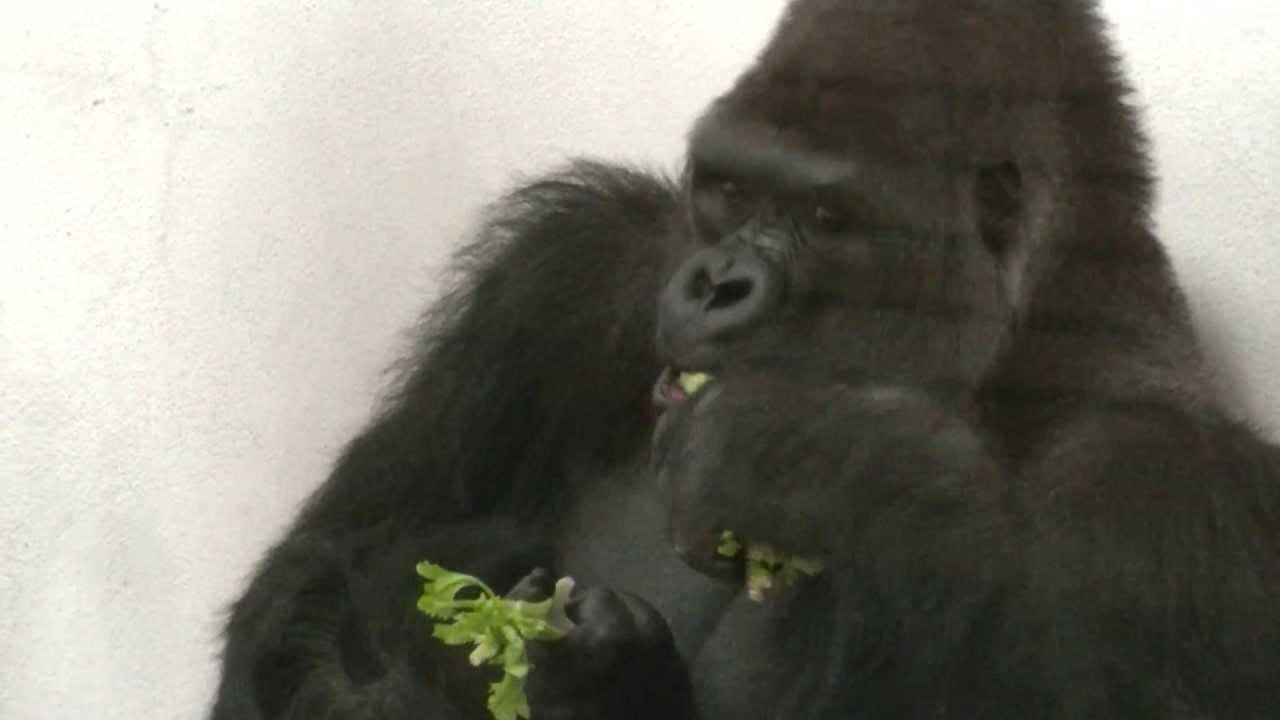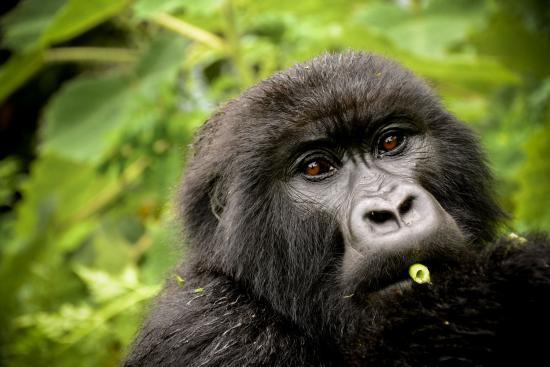The first image is the image on the left, the second image is the image on the right. Analyze the images presented: Is the assertion "In the right image, a gorilla is holding green foliage to its mouth with the arm on the left [of the image]." valid? Answer yes or no. No. The first image is the image on the left, the second image is the image on the right. Considering the images on both sides, is "All of the gorillas are holding food in their left hand." valid? Answer yes or no. No. 